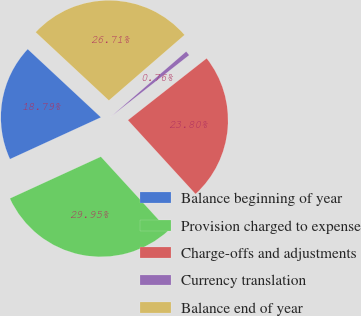<chart> <loc_0><loc_0><loc_500><loc_500><pie_chart><fcel>Balance beginning of year<fcel>Provision charged to expense<fcel>Charge-offs and adjustments<fcel>Currency translation<fcel>Balance end of year<nl><fcel>18.79%<fcel>29.95%<fcel>23.8%<fcel>0.76%<fcel>26.71%<nl></chart> 